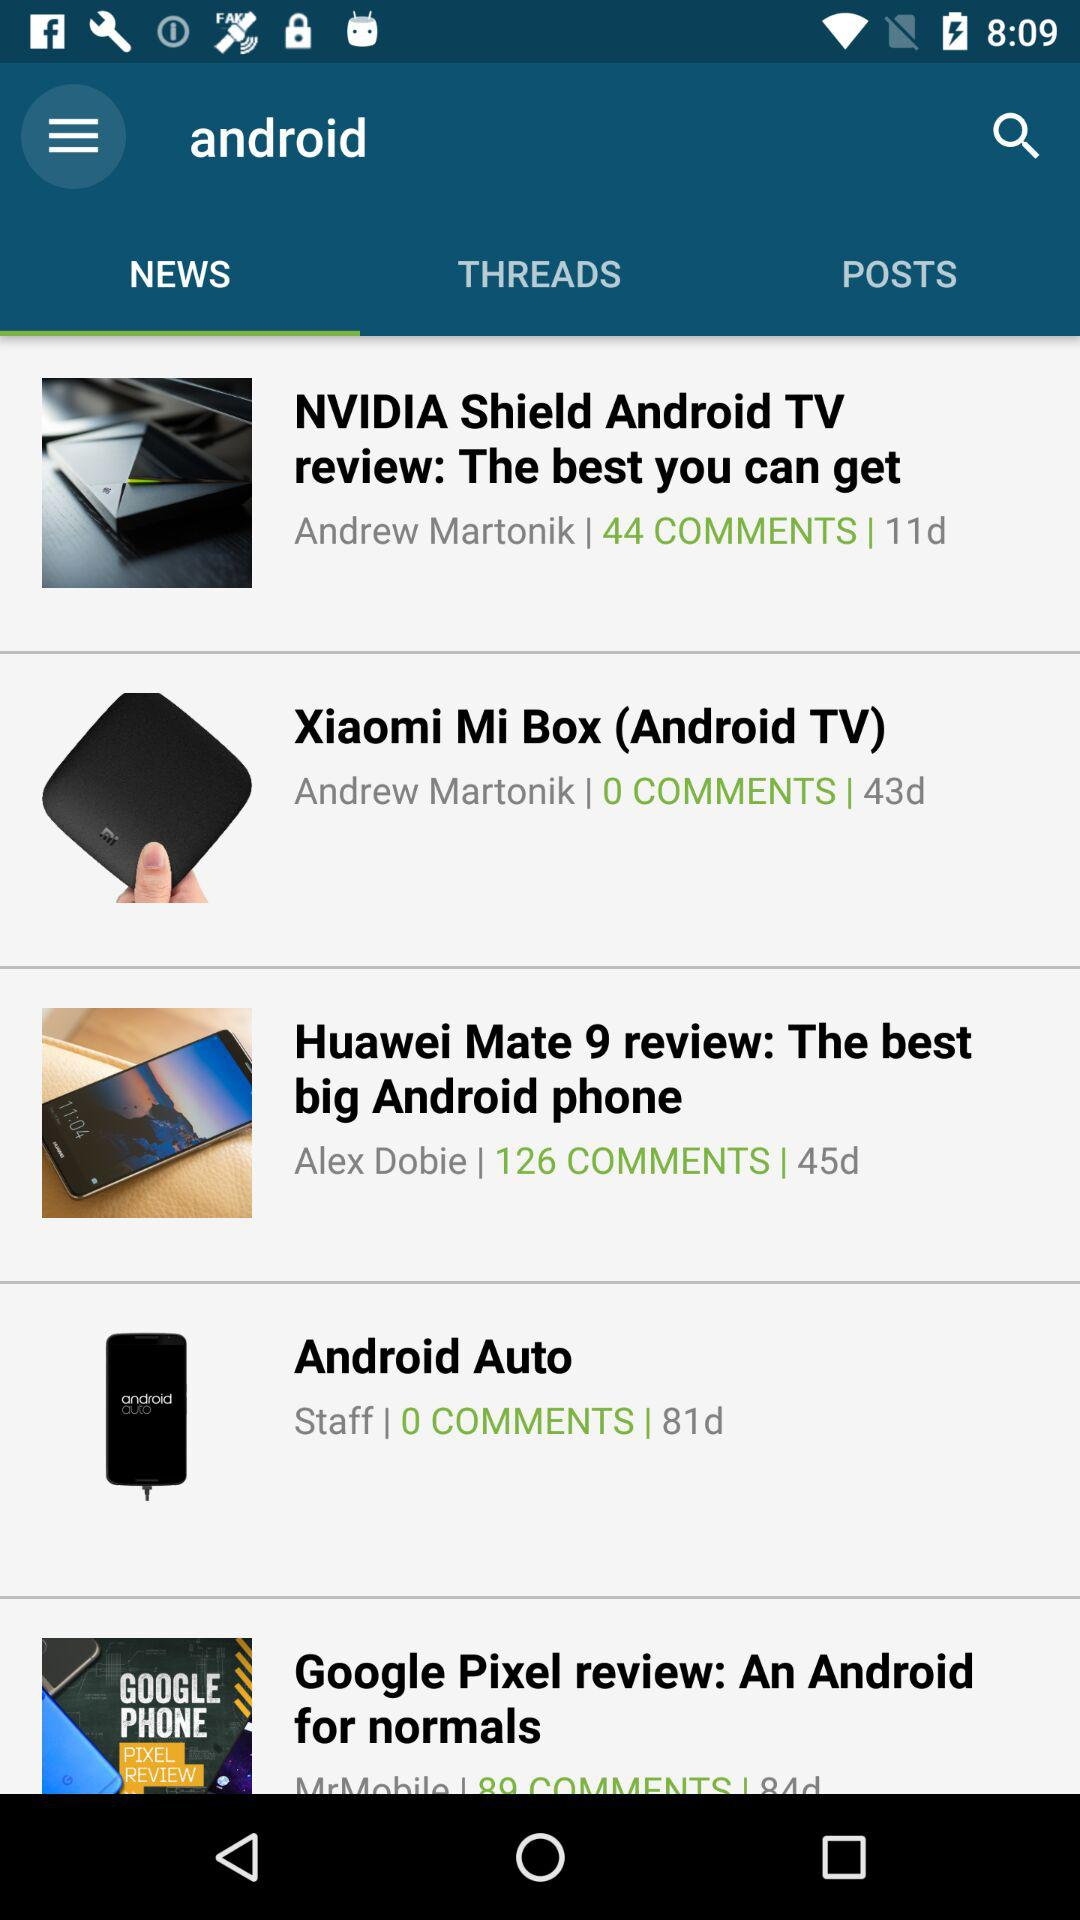How many comments are there on "Android Auto"? There are 0 comments on "Android Auto". 